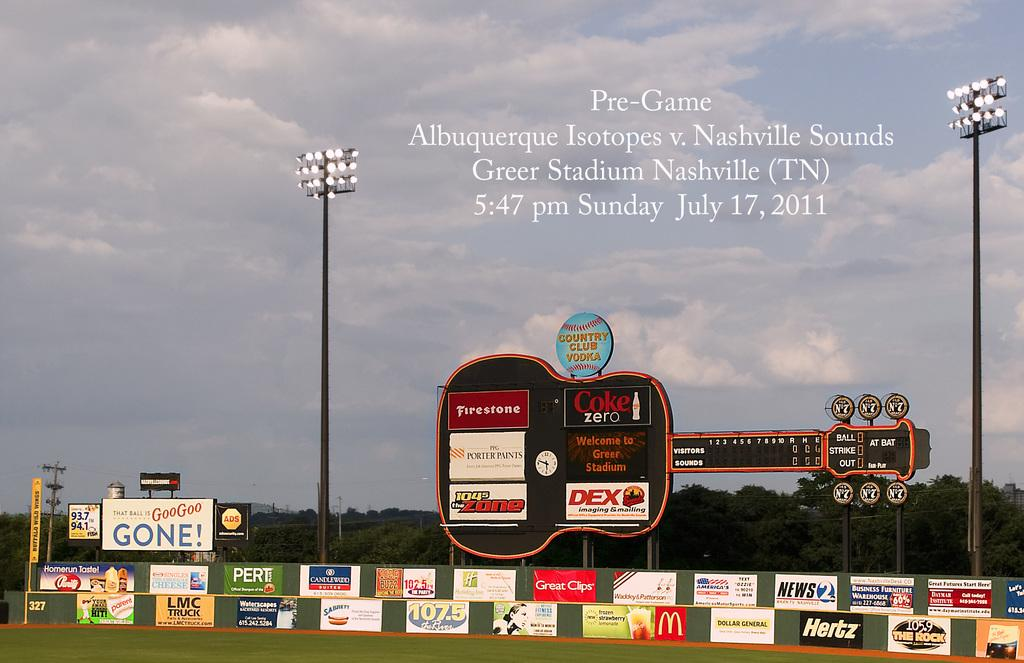<image>
Provide a brief description of the given image. A sport's field has a huge guitar shaped scoreboard with advertisements Firestone, Coke Zero, Hertz, Great Clips, and more on it and on the wall. 